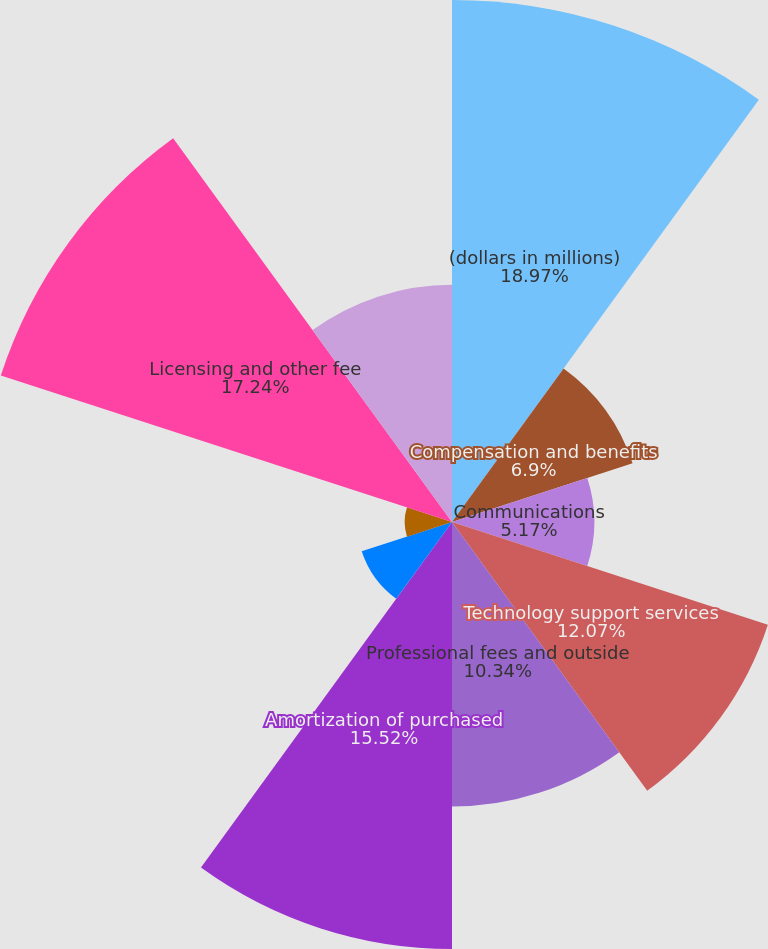<chart> <loc_0><loc_0><loc_500><loc_500><pie_chart><fcel>(dollars in millions)<fcel>Compensation and benefits<fcel>Communications<fcel>Technology support services<fcel>Professional fees and outside<fcel>Amortization of purchased<fcel>Depreciation and amortization<fcel>Occupancy and building<fcel>Licensing and other fee<fcel>Restructuring<nl><fcel>18.97%<fcel>6.9%<fcel>5.17%<fcel>12.07%<fcel>10.34%<fcel>15.52%<fcel>3.45%<fcel>1.72%<fcel>17.24%<fcel>8.62%<nl></chart> 